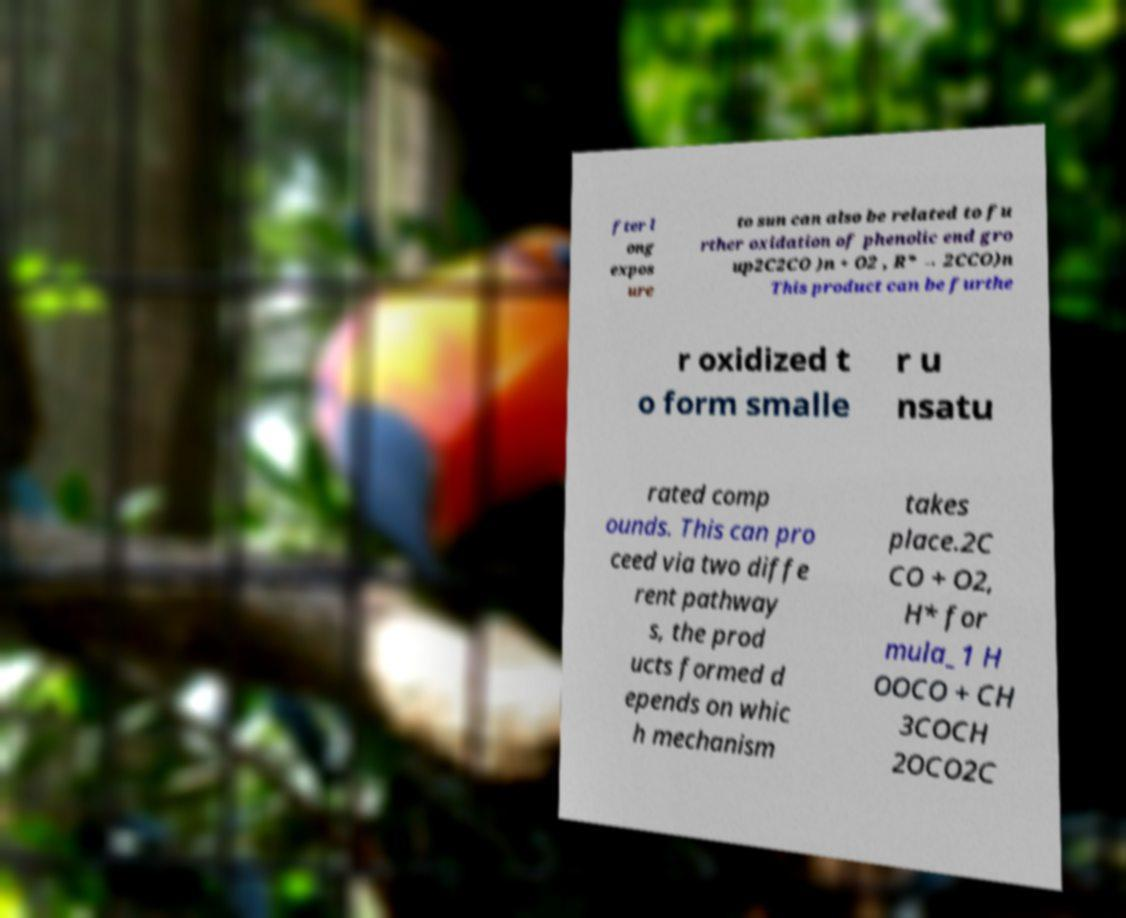For documentation purposes, I need the text within this image transcribed. Could you provide that? fter l ong expos ure to sun can also be related to fu rther oxidation of phenolic end gro up2C2CO )n + O2 , R* → 2CCO)n This product can be furthe r oxidized t o form smalle r u nsatu rated comp ounds. This can pro ceed via two diffe rent pathway s, the prod ucts formed d epends on whic h mechanism takes place.2C CO + O2, H* for mula_1 H OOCO + CH 3COCH 2OCO2C 